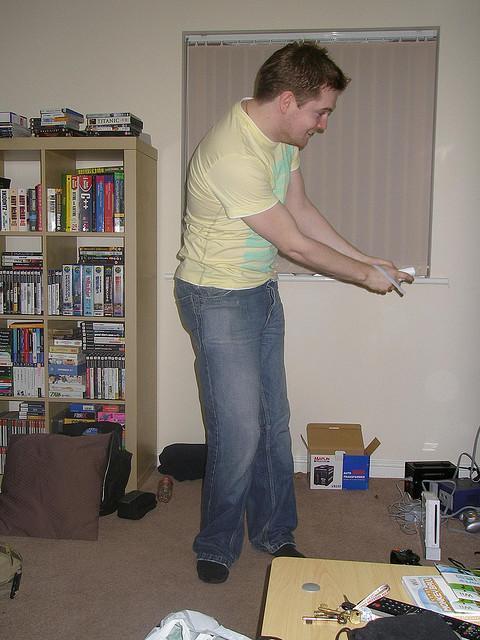How many people are playing Wii?
Give a very brief answer. 1. How many books are there?
Give a very brief answer. 2. 